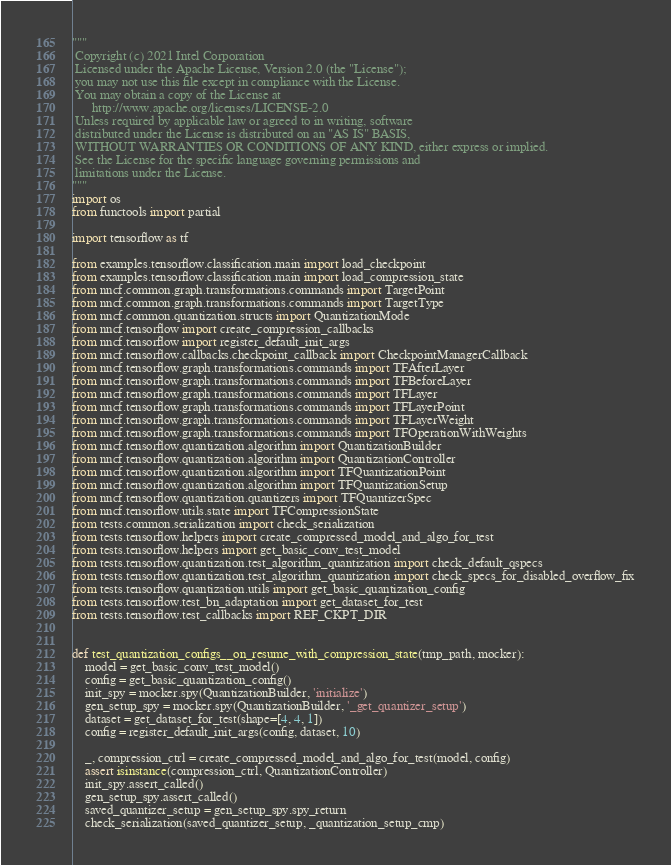Convert code to text. <code><loc_0><loc_0><loc_500><loc_500><_Python_>"""
 Copyright (c) 2021 Intel Corporation
 Licensed under the Apache License, Version 2.0 (the "License");
 you may not use this file except in compliance with the License.
 You may obtain a copy of the License at
      http://www.apache.org/licenses/LICENSE-2.0
 Unless required by applicable law or agreed to in writing, software
 distributed under the License is distributed on an "AS IS" BASIS,
 WITHOUT WARRANTIES OR CONDITIONS OF ANY KIND, either express or implied.
 See the License for the specific language governing permissions and
 limitations under the License.
"""
import os
from functools import partial

import tensorflow as tf

from examples.tensorflow.classification.main import load_checkpoint
from examples.tensorflow.classification.main import load_compression_state
from nncf.common.graph.transformations.commands import TargetPoint
from nncf.common.graph.transformations.commands import TargetType
from nncf.common.quantization.structs import QuantizationMode
from nncf.tensorflow import create_compression_callbacks
from nncf.tensorflow import register_default_init_args
from nncf.tensorflow.callbacks.checkpoint_callback import CheckpointManagerCallback
from nncf.tensorflow.graph.transformations.commands import TFAfterLayer
from nncf.tensorflow.graph.transformations.commands import TFBeforeLayer
from nncf.tensorflow.graph.transformations.commands import TFLayer
from nncf.tensorflow.graph.transformations.commands import TFLayerPoint
from nncf.tensorflow.graph.transformations.commands import TFLayerWeight
from nncf.tensorflow.graph.transformations.commands import TFOperationWithWeights
from nncf.tensorflow.quantization.algorithm import QuantizationBuilder
from nncf.tensorflow.quantization.algorithm import QuantizationController
from nncf.tensorflow.quantization.algorithm import TFQuantizationPoint
from nncf.tensorflow.quantization.algorithm import TFQuantizationSetup
from nncf.tensorflow.quantization.quantizers import TFQuantizerSpec
from nncf.tensorflow.utils.state import TFCompressionState
from tests.common.serialization import check_serialization
from tests.tensorflow.helpers import create_compressed_model_and_algo_for_test
from tests.tensorflow.helpers import get_basic_conv_test_model
from tests.tensorflow.quantization.test_algorithm_quantization import check_default_qspecs
from tests.tensorflow.quantization.test_algorithm_quantization import check_specs_for_disabled_overflow_fix
from tests.tensorflow.quantization.utils import get_basic_quantization_config
from tests.tensorflow.test_bn_adaptation import get_dataset_for_test
from tests.tensorflow.test_callbacks import REF_CKPT_DIR


def test_quantization_configs__on_resume_with_compression_state(tmp_path, mocker):
    model = get_basic_conv_test_model()
    config = get_basic_quantization_config()
    init_spy = mocker.spy(QuantizationBuilder, 'initialize')
    gen_setup_spy = mocker.spy(QuantizationBuilder, '_get_quantizer_setup')
    dataset = get_dataset_for_test(shape=[4, 4, 1])
    config = register_default_init_args(config, dataset, 10)

    _, compression_ctrl = create_compressed_model_and_algo_for_test(model, config)
    assert isinstance(compression_ctrl, QuantizationController)
    init_spy.assert_called()
    gen_setup_spy.assert_called()
    saved_quantizer_setup = gen_setup_spy.spy_return
    check_serialization(saved_quantizer_setup, _quantization_setup_cmp)
</code> 